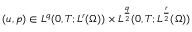Convert formula to latex. <formula><loc_0><loc_0><loc_500><loc_500>( u , p ) \in L ^ { q } ( 0 , T ; L ^ { r } ( \Omega ) ) \times L ^ { \frac { q } { 2 } } ( 0 , T ; L ^ { \frac { r } { 2 } } ( \Omega ) )</formula> 